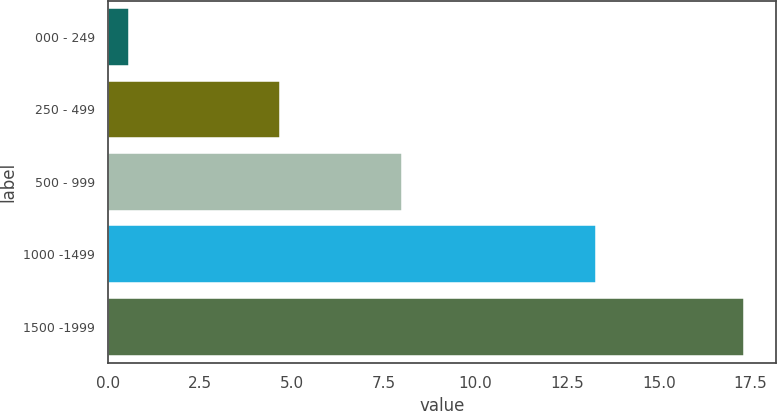Convert chart. <chart><loc_0><loc_0><loc_500><loc_500><bar_chart><fcel>000 - 249<fcel>250 - 499<fcel>500 - 999<fcel>1000 -1499<fcel>1500 -1999<nl><fcel>0.58<fcel>4.67<fcel>8<fcel>13.28<fcel>17.32<nl></chart> 